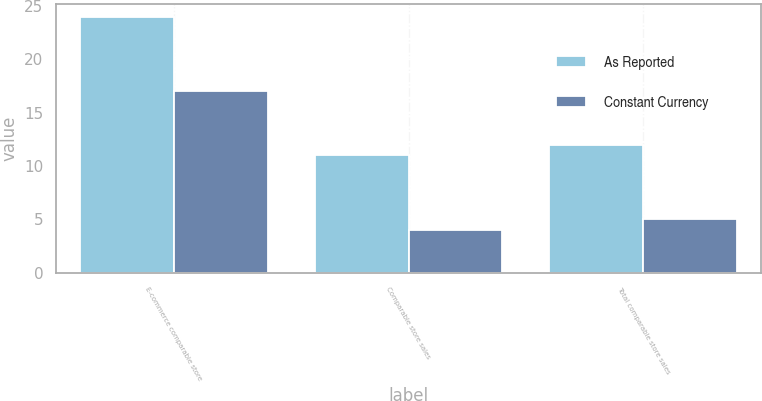Convert chart. <chart><loc_0><loc_0><loc_500><loc_500><stacked_bar_chart><ecel><fcel>E-commerce comparable store<fcel>Comparable store sales<fcel>Total comparable store sales<nl><fcel>As Reported<fcel>24<fcel>11<fcel>12<nl><fcel>Constant Currency<fcel>17<fcel>4<fcel>5<nl></chart> 